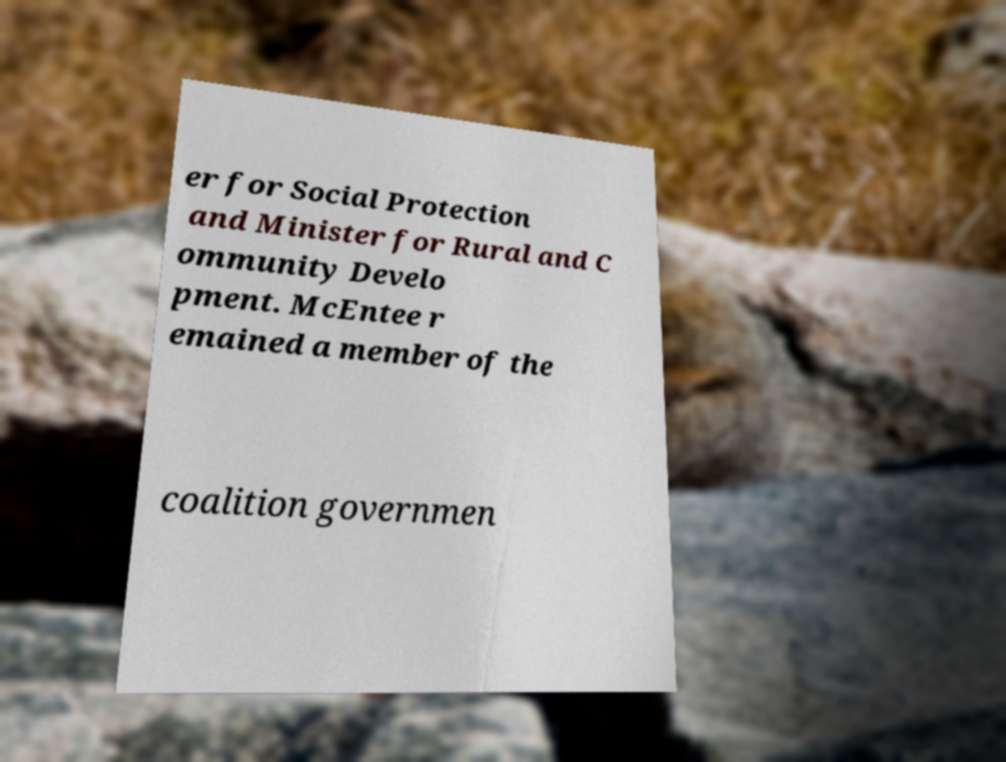Please identify and transcribe the text found in this image. er for Social Protection and Minister for Rural and C ommunity Develo pment. McEntee r emained a member of the coalition governmen 